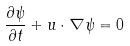Convert formula to latex. <formula><loc_0><loc_0><loc_500><loc_500>\frac { \partial \psi } { \partial t } + u \cdot \nabla \psi = 0</formula> 